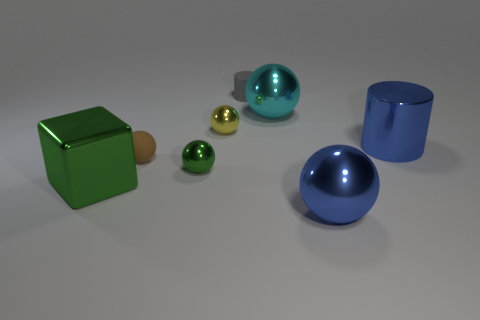How many big objects are in front of the brown matte sphere and to the right of the green sphere?
Provide a succinct answer. 1. Are there fewer tiny green shiny things left of the small brown thing than cubes to the right of the cyan ball?
Offer a very short reply. No. Does the cyan metallic thing have the same shape as the brown rubber object?
Your answer should be compact. Yes. How many other things are the same size as the metallic cylinder?
Make the answer very short. 3. What number of things are either metal objects that are behind the blue shiny sphere or large green cubes behind the blue shiny ball?
Provide a succinct answer. 5. What number of other matte things are the same shape as the brown rubber thing?
Ensure brevity in your answer.  0. There is a sphere that is right of the tiny cylinder and in front of the tiny matte ball; what material is it?
Your answer should be compact. Metal. How many green things are in front of the blue metallic cylinder?
Give a very brief answer. 2. What number of green metal objects are there?
Provide a succinct answer. 2. Do the green shiny sphere and the matte sphere have the same size?
Make the answer very short. Yes. 